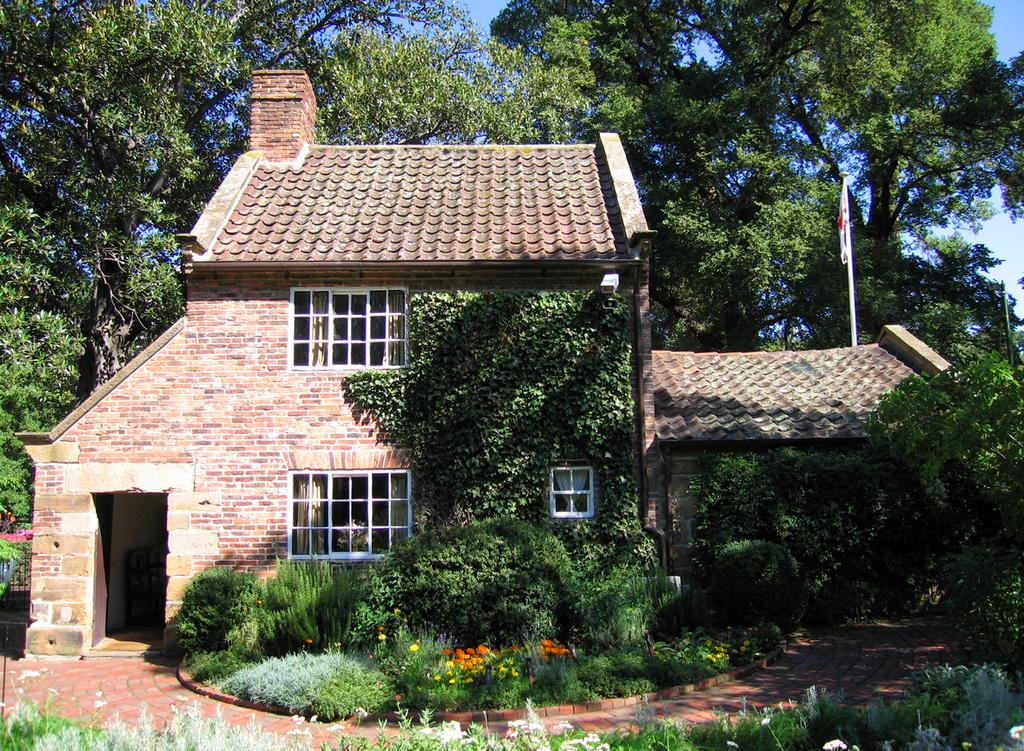What type of structure is visible in the image? There is a house in the image. What type of vegetation can be seen in the image? There are plants, trees, flowers, and grass visible in the image. What architectural feature is present in the image? There is a fence in the image. What is the colorful object visible in the image? There is a flag in the image. What part of the natural environment is visible in the image? The sky is visible in the background of the image. How many pies are being baked in the oven in the image? There is no oven or pies present in the image. What type of canvas is being used to paint the house in the image? There is no canvas or painting activity present in the image. 